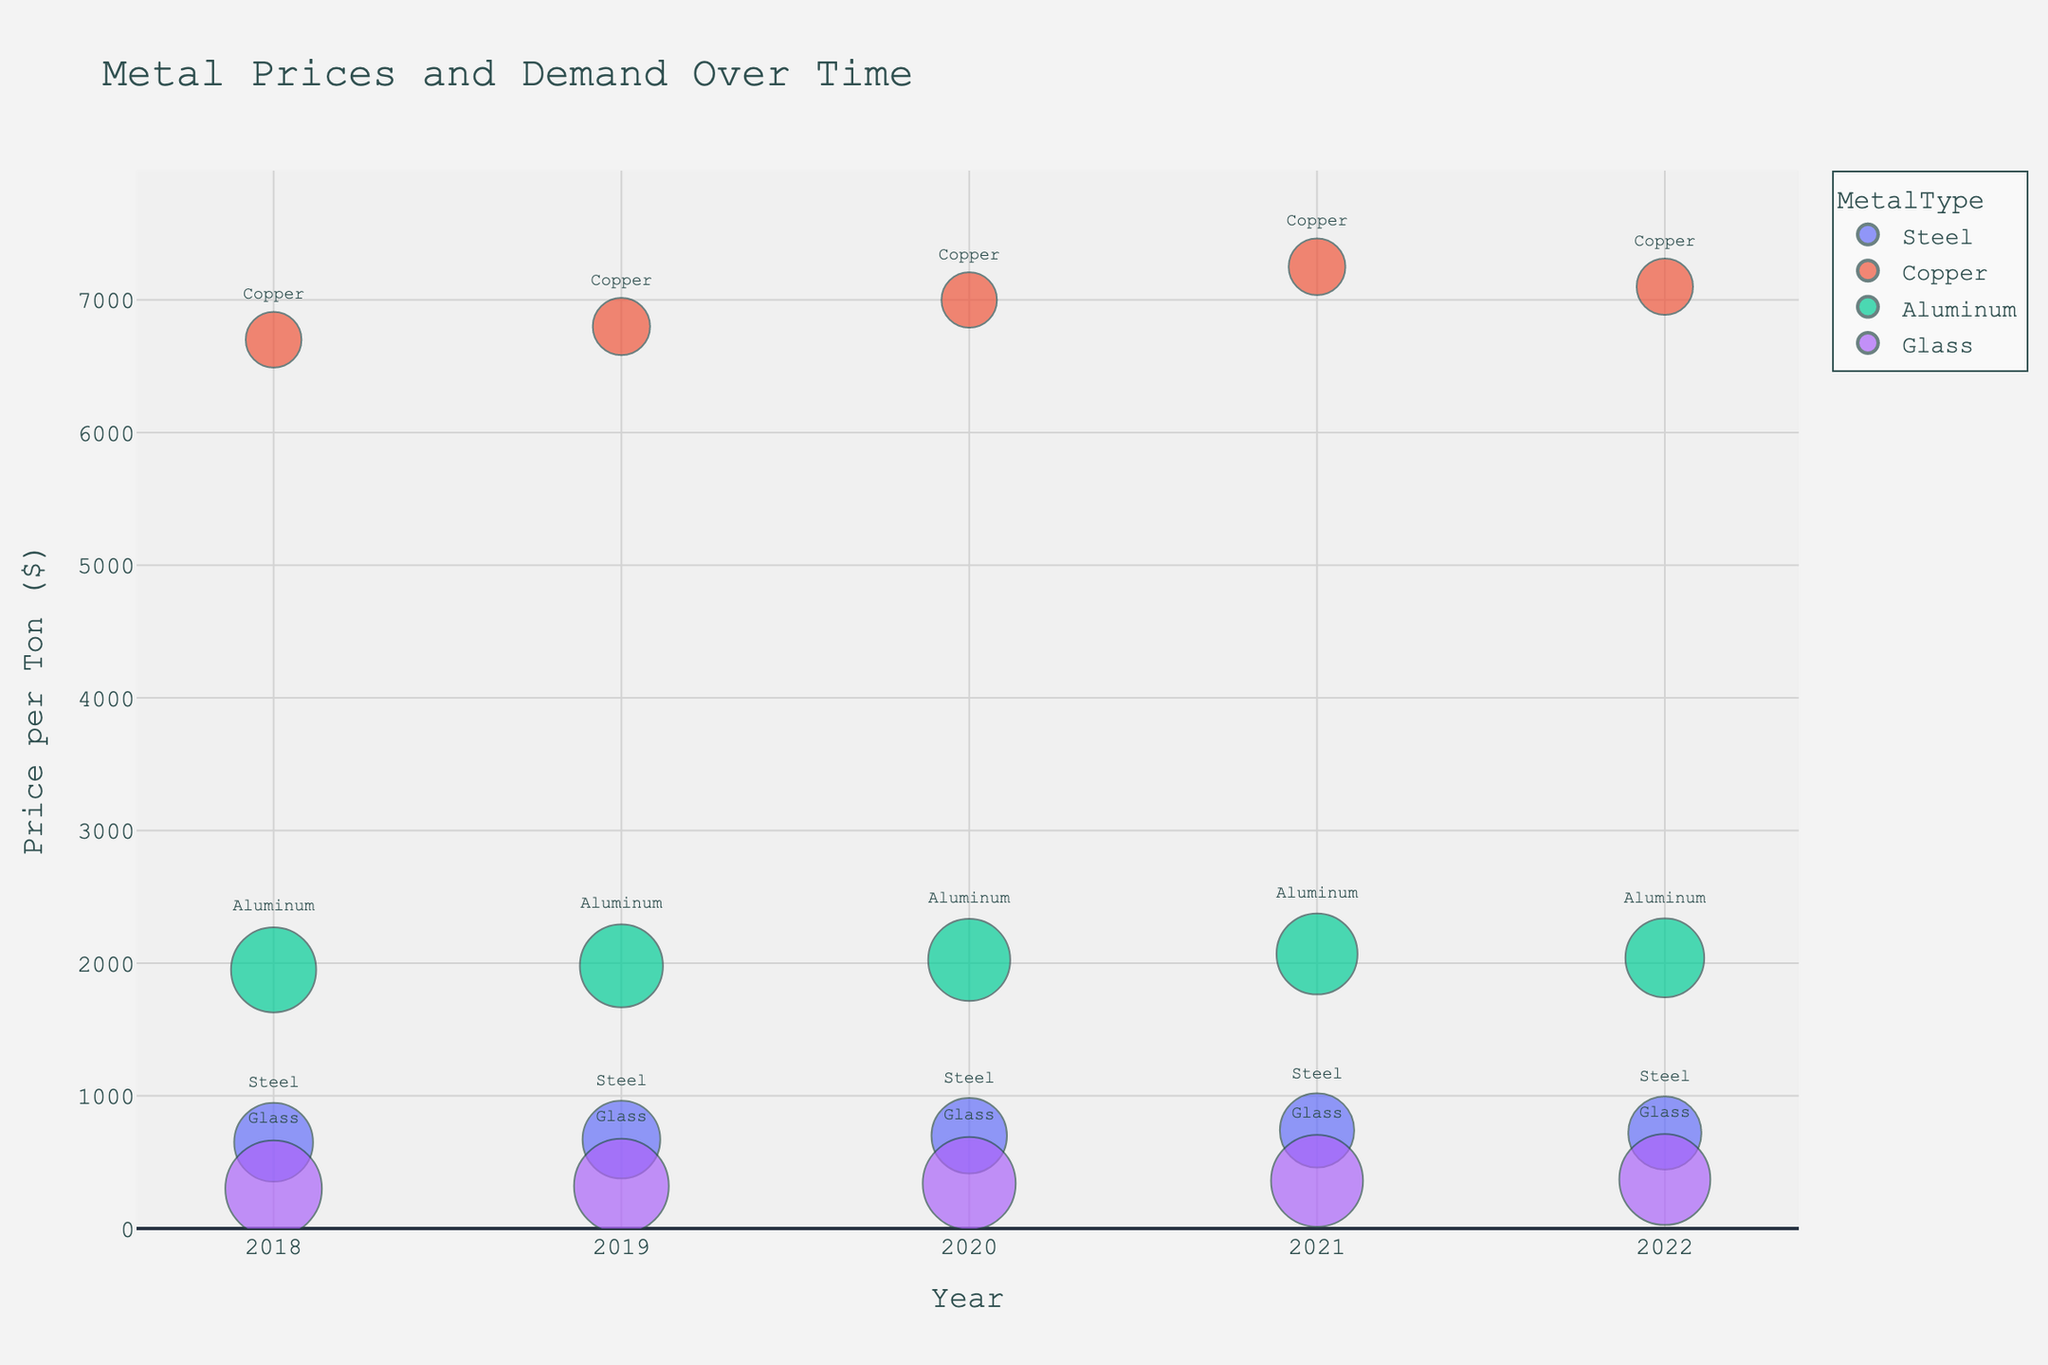What's the trend in Steel prices over the years from 2018 to 2022? The Steel prices show an overall increasing trend with a slight fluctuation. Starting at $650 in 2018, the prices rise to $740 in 2021, followed by a slight drop to $720 in 2022.
Answer: Increasing trend with a slight fluctuation Which metal had the highest price per ton in 2020? By observing the y-axis value for different metals in 2020, Copper shows the highest price per ton at $7000.
Answer: Copper How does the demand for aluminum change from 2018 to 2022? The bubble size representing aluminum decreases over time, indicating a reduction in demand. It drops from 2100 tons in 2018 to 1800 tons in 2022.
Answer: Decreases What is the average price of Glass from 2018 to 2022? Adding the prices of Glass for each year (300, 320, 340, 360, 370) and dividing by the number of years (5): (300 + 320 + 340 + 360 + 370) / 5 = 338.
Answer: $338 Which metal experienced the largest demand in 2019? The largest bubble size in 2019, representing demand, is for Glass at 2600 tons.
Answer: Glass How does the price trend of Aluminum compare to Copper from 2018 to 2022? Both Aluminum and Copper generally increase in price over the period. However, Copper sees a higher absolute price change and a more noticeable fluctuation compared to the relatively steady increase of Aluminum.
Answer: Both increase; Copper fluctuates more Which metal had the most stable price from 2018 to 2022? The metal with the least fluctuation on the y-axis, which is Aluminum, showing a gradual and consistent rise.
Answer: Aluminum Is there a correlation between price and demand for Steel over the years? Analyzing the chart, as the price of Steel increases overall from 2018 to 2022, the demand decreases, suggesting a negative correlation between price and demand for Steel.
Answer: Negative correlation How does the demand for Copper compare to Steel in 2022? Comparing the bubble sizes for Copper and Steel in 2022, Steel has a larger bubble representing a higher demand at 1550 tons, whereas Copper has 920 tons.
Answer: Steel demand is higher 